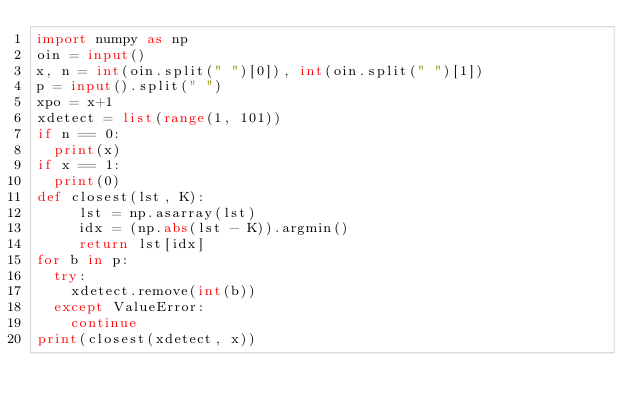<code> <loc_0><loc_0><loc_500><loc_500><_Python_>import numpy as np
oin = input()
x, n = int(oin.split(" ")[0]), int(oin.split(" ")[1])
p = input().split(" ")
xpo = x+1
xdetect = list(range(1, 101))
if n == 0:
  print(x)
if x == 1:
  print(0)
def closest(lst, K): 
     lst = np.asarray(lst) 
     idx = (np.abs(lst - K)).argmin()
     return lst[idx]
for b in p:
  try:
    xdetect.remove(int(b))
  except ValueError:
    continue
print(closest(xdetect, x))</code> 